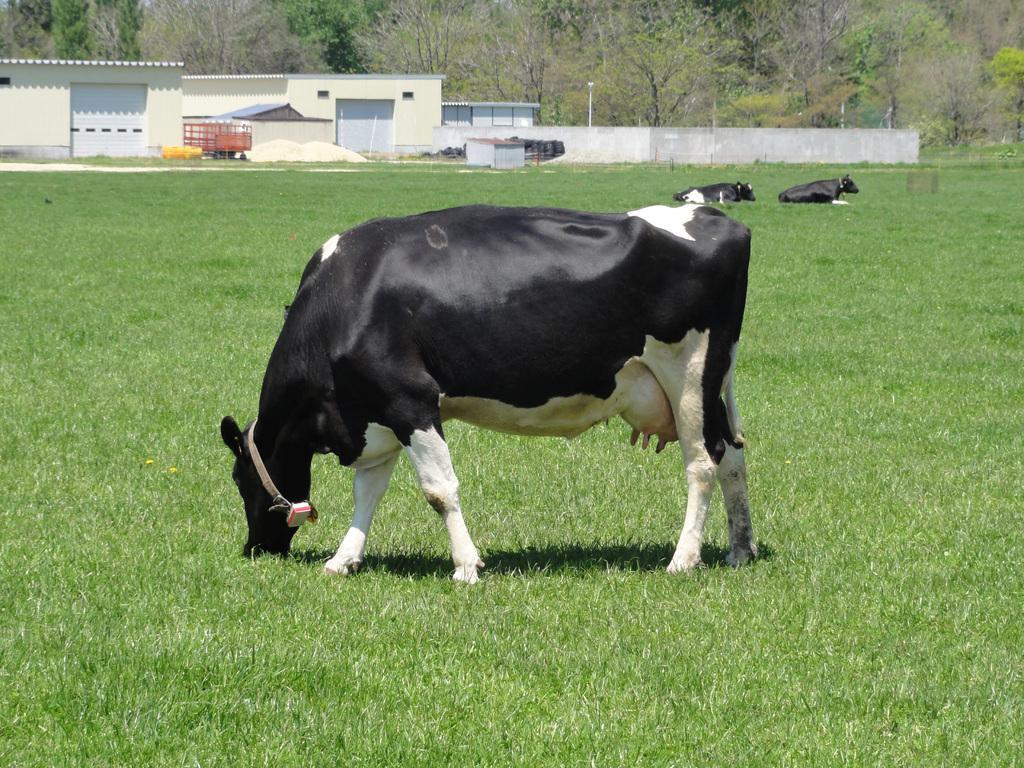Can you describe this image briefly? In this image we can see some cows on the grass field. On the backside we can see the shed with shutters, the metal frame, a wall, some poles and a group of trees. 